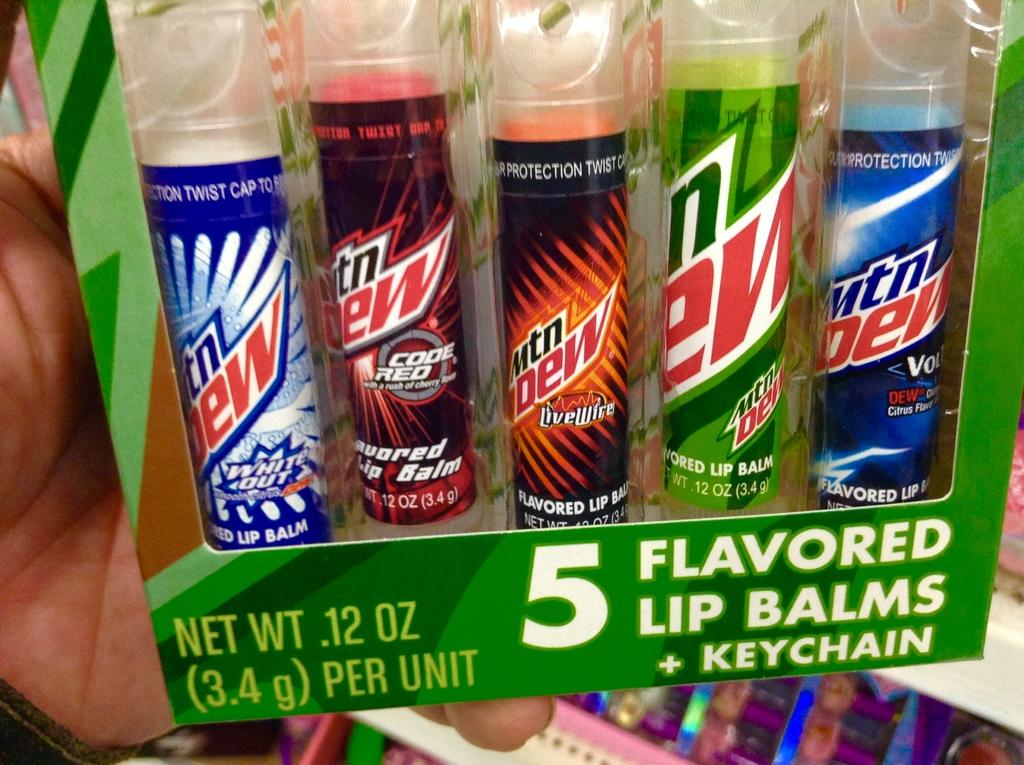<image>
Create a compact narrative representing the image presented. the words mountain dew that are on some items 